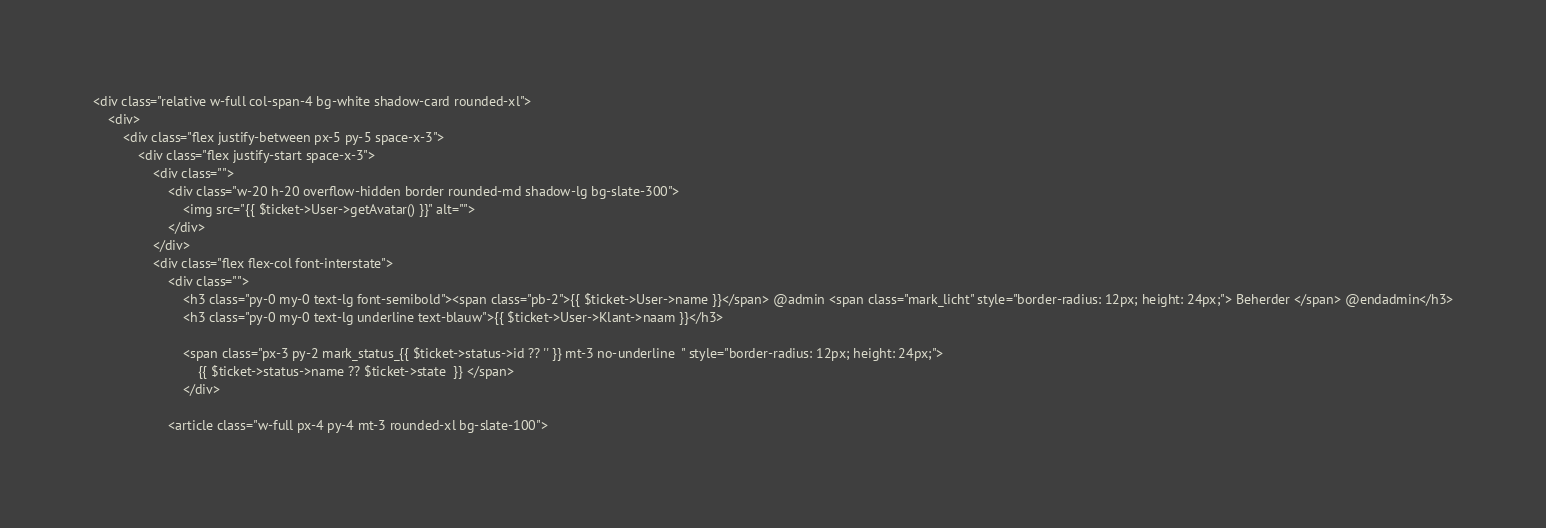<code> <loc_0><loc_0><loc_500><loc_500><_PHP_><div class="relative w-full col-span-4 bg-white shadow-card rounded-xl">
    <div>
        <div class="flex justify-between px-5 py-5 space-x-3">
            <div class="flex justify-start space-x-3">
                <div class="">
                    <div class="w-20 h-20 overflow-hidden border rounded-md shadow-lg bg-slate-300">
                        <img src="{{ $ticket->User->getAvatar() }}" alt="">
                    </div>
                </div>
                <div class="flex flex-col font-interstate">
                    <div class="">
                        <h3 class="py-0 my-0 text-lg font-semibold"><span class="pb-2">{{ $ticket->User->name }}</span> @admin <span class="mark_licht" style="border-radius: 12px; height: 24px;"> Beherder </span> @endadmin</h3>
                        <h3 class="py-0 my-0 text-lg underline text-blauw">{{ $ticket->User->Klant->naam }}</h3>

                        <span class="px-3 py-2 mark_status_{{ $ticket->status->id ?? '' }} mt-3 no-underline  " style="border-radius: 12px; height: 24px;">
                            {{ $ticket->status->name ?? $ticket->state  }} </span>
                        </div>

                    <article class="w-full px-4 py-4 mt-3 rounded-xl bg-slate-100"></code> 